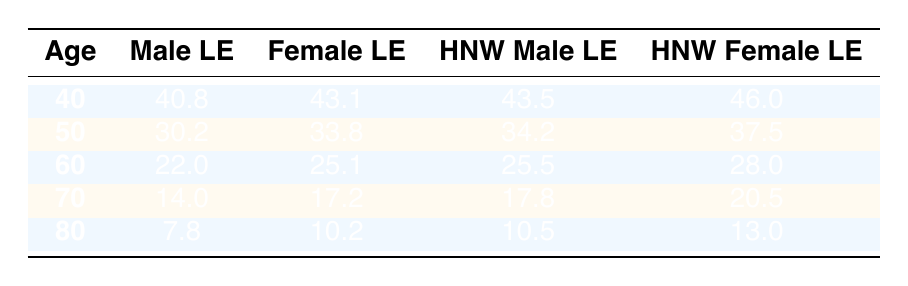What is the life expectancy for 60-year-old high-net-worth males? Referring to the table, the life expectancy for 60-year-old high-net-worth males is specifically listed under the "High_Net_Worth_Male_Life_Expectancy" column corresponding to the age of 60. That value is 25.5 years.
Answer: 25.5 What is the difference in life expectancy between high-net-worth females and average females at age 70? At age 70, the life expectancy for high-net-worth females is 20.5 years, while for average females it is 17.2 years. The difference is calculated as 20.5 - 17.2 = 3.3 years.
Answer: 3.3 Is the life expectancy for high-net-worth males at age 50 higher than that for average males at the same age? The life expectancy for high-net-worth males at age 50 is 34.2 years, while the average male life expectancy at age 50 is 30.2 years. Since 34.2 > 30.2, the statement is true.
Answer: Yes What is the average life expectancy for high-net-worth individuals, regardless of gender, at the age of 40? To find the average life expectancy at age 40, add the high-net-worth male and female life expectancies: (43.5 + 46.0) / 2 = 44.75 years.
Answer: 44.75 What is the life expectancy for an 80-year-old high-net-worth female compared to an average male of the same age? The life expectancy for an 80-year-old high-net-worth female is 13.0 years, while for an average male at the same age it is 7.8 years. Hence, high-net-worth females live longer than average males by an amount of 13.0 - 7.8 = 5.2 years.
Answer: 5.2 What is the table value for the average life expectancy of 70-year-old males? In the data, the average life expectancy provided for 70-year-old males is listed directly under the "Male_Life_Expectancy" column for that age, which is 14.0 years.
Answer: 14.0 Do high-net-worth females have a longer life expectancy than average females at age 60? The life expectancy for high-net-worth females at age 60 is 28.0 years. The average female life expectancy at that age is 25.1 years. Since 28.0 > 25.1, this statement is true.
Answer: Yes What is the total life expectancy for high-net-worth males at ages 40 and 50 combined? To find the total life expectancy for high-net-worth males at ages 40 and 50, add the life expectancies: 43.5 (age 40) + 34.2 (age 50) = 77.7 years.
Answer: 77.7 